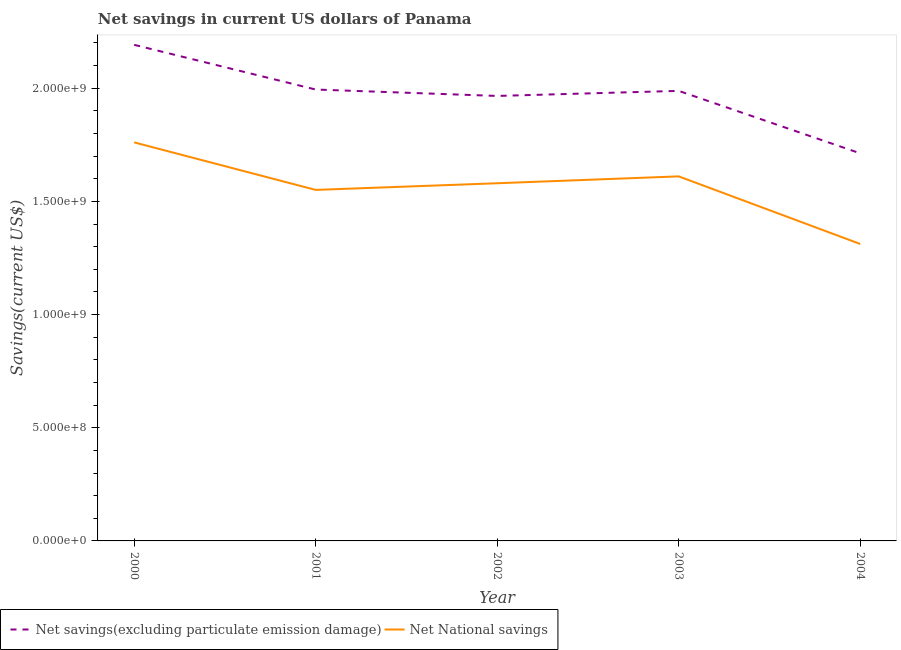What is the net national savings in 2000?
Keep it short and to the point. 1.76e+09. Across all years, what is the maximum net national savings?
Give a very brief answer. 1.76e+09. Across all years, what is the minimum net savings(excluding particulate emission damage)?
Make the answer very short. 1.71e+09. In which year was the net savings(excluding particulate emission damage) maximum?
Keep it short and to the point. 2000. In which year was the net national savings minimum?
Keep it short and to the point. 2004. What is the total net national savings in the graph?
Your answer should be compact. 7.81e+09. What is the difference between the net savings(excluding particulate emission damage) in 2002 and that in 2003?
Keep it short and to the point. -2.24e+07. What is the difference between the net savings(excluding particulate emission damage) in 2001 and the net national savings in 2002?
Make the answer very short. 4.14e+08. What is the average net national savings per year?
Offer a terse response. 1.56e+09. In the year 2003, what is the difference between the net national savings and net savings(excluding particulate emission damage)?
Offer a very short reply. -3.78e+08. What is the ratio of the net savings(excluding particulate emission damage) in 2000 to that in 2001?
Offer a very short reply. 1.1. What is the difference between the highest and the second highest net savings(excluding particulate emission damage)?
Provide a succinct answer. 1.97e+08. What is the difference between the highest and the lowest net national savings?
Provide a short and direct response. 4.49e+08. In how many years, is the net national savings greater than the average net national savings taken over all years?
Keep it short and to the point. 3. Does the net national savings monotonically increase over the years?
Your response must be concise. No. Is the net savings(excluding particulate emission damage) strictly greater than the net national savings over the years?
Your answer should be very brief. Yes. How many years are there in the graph?
Your answer should be compact. 5. Are the values on the major ticks of Y-axis written in scientific E-notation?
Provide a succinct answer. Yes. Does the graph contain grids?
Ensure brevity in your answer.  No. Where does the legend appear in the graph?
Provide a succinct answer. Bottom left. How are the legend labels stacked?
Keep it short and to the point. Horizontal. What is the title of the graph?
Offer a very short reply. Net savings in current US dollars of Panama. Does "State government" appear as one of the legend labels in the graph?
Provide a succinct answer. No. What is the label or title of the X-axis?
Your answer should be very brief. Year. What is the label or title of the Y-axis?
Keep it short and to the point. Savings(current US$). What is the Savings(current US$) of Net savings(excluding particulate emission damage) in 2000?
Offer a terse response. 2.19e+09. What is the Savings(current US$) in Net National savings in 2000?
Offer a very short reply. 1.76e+09. What is the Savings(current US$) in Net savings(excluding particulate emission damage) in 2001?
Offer a terse response. 1.99e+09. What is the Savings(current US$) in Net National savings in 2001?
Offer a very short reply. 1.55e+09. What is the Savings(current US$) in Net savings(excluding particulate emission damage) in 2002?
Make the answer very short. 1.97e+09. What is the Savings(current US$) of Net National savings in 2002?
Keep it short and to the point. 1.58e+09. What is the Savings(current US$) in Net savings(excluding particulate emission damage) in 2003?
Your answer should be compact. 1.99e+09. What is the Savings(current US$) in Net National savings in 2003?
Provide a short and direct response. 1.61e+09. What is the Savings(current US$) of Net savings(excluding particulate emission damage) in 2004?
Offer a terse response. 1.71e+09. What is the Savings(current US$) of Net National savings in 2004?
Offer a very short reply. 1.31e+09. Across all years, what is the maximum Savings(current US$) in Net savings(excluding particulate emission damage)?
Keep it short and to the point. 2.19e+09. Across all years, what is the maximum Savings(current US$) in Net National savings?
Offer a very short reply. 1.76e+09. Across all years, what is the minimum Savings(current US$) of Net savings(excluding particulate emission damage)?
Keep it short and to the point. 1.71e+09. Across all years, what is the minimum Savings(current US$) of Net National savings?
Make the answer very short. 1.31e+09. What is the total Savings(current US$) in Net savings(excluding particulate emission damage) in the graph?
Make the answer very short. 9.85e+09. What is the total Savings(current US$) of Net National savings in the graph?
Offer a terse response. 7.81e+09. What is the difference between the Savings(current US$) of Net savings(excluding particulate emission damage) in 2000 and that in 2001?
Ensure brevity in your answer.  1.97e+08. What is the difference between the Savings(current US$) of Net National savings in 2000 and that in 2001?
Your response must be concise. 2.10e+08. What is the difference between the Savings(current US$) in Net savings(excluding particulate emission damage) in 2000 and that in 2002?
Your answer should be compact. 2.26e+08. What is the difference between the Savings(current US$) of Net National savings in 2000 and that in 2002?
Your answer should be very brief. 1.80e+08. What is the difference between the Savings(current US$) in Net savings(excluding particulate emission damage) in 2000 and that in 2003?
Provide a succinct answer. 2.03e+08. What is the difference between the Savings(current US$) in Net National savings in 2000 and that in 2003?
Make the answer very short. 1.50e+08. What is the difference between the Savings(current US$) in Net savings(excluding particulate emission damage) in 2000 and that in 2004?
Offer a very short reply. 4.79e+08. What is the difference between the Savings(current US$) of Net National savings in 2000 and that in 2004?
Your response must be concise. 4.49e+08. What is the difference between the Savings(current US$) in Net savings(excluding particulate emission damage) in 2001 and that in 2002?
Offer a very short reply. 2.83e+07. What is the difference between the Savings(current US$) of Net National savings in 2001 and that in 2002?
Your answer should be compact. -2.94e+07. What is the difference between the Savings(current US$) of Net savings(excluding particulate emission damage) in 2001 and that in 2003?
Ensure brevity in your answer.  5.92e+06. What is the difference between the Savings(current US$) in Net National savings in 2001 and that in 2003?
Provide a succinct answer. -5.98e+07. What is the difference between the Savings(current US$) in Net savings(excluding particulate emission damage) in 2001 and that in 2004?
Give a very brief answer. 2.82e+08. What is the difference between the Savings(current US$) in Net National savings in 2001 and that in 2004?
Provide a succinct answer. 2.39e+08. What is the difference between the Savings(current US$) in Net savings(excluding particulate emission damage) in 2002 and that in 2003?
Your answer should be very brief. -2.24e+07. What is the difference between the Savings(current US$) in Net National savings in 2002 and that in 2003?
Ensure brevity in your answer.  -3.04e+07. What is the difference between the Savings(current US$) in Net savings(excluding particulate emission damage) in 2002 and that in 2004?
Your answer should be very brief. 2.54e+08. What is the difference between the Savings(current US$) in Net National savings in 2002 and that in 2004?
Make the answer very short. 2.68e+08. What is the difference between the Savings(current US$) of Net savings(excluding particulate emission damage) in 2003 and that in 2004?
Your answer should be very brief. 2.76e+08. What is the difference between the Savings(current US$) in Net National savings in 2003 and that in 2004?
Provide a short and direct response. 2.99e+08. What is the difference between the Savings(current US$) in Net savings(excluding particulate emission damage) in 2000 and the Savings(current US$) in Net National savings in 2001?
Ensure brevity in your answer.  6.41e+08. What is the difference between the Savings(current US$) of Net savings(excluding particulate emission damage) in 2000 and the Savings(current US$) of Net National savings in 2002?
Offer a very short reply. 6.11e+08. What is the difference between the Savings(current US$) of Net savings(excluding particulate emission damage) in 2000 and the Savings(current US$) of Net National savings in 2003?
Provide a succinct answer. 5.81e+08. What is the difference between the Savings(current US$) of Net savings(excluding particulate emission damage) in 2000 and the Savings(current US$) of Net National savings in 2004?
Ensure brevity in your answer.  8.80e+08. What is the difference between the Savings(current US$) in Net savings(excluding particulate emission damage) in 2001 and the Savings(current US$) in Net National savings in 2002?
Your answer should be compact. 4.14e+08. What is the difference between the Savings(current US$) in Net savings(excluding particulate emission damage) in 2001 and the Savings(current US$) in Net National savings in 2003?
Offer a very short reply. 3.84e+08. What is the difference between the Savings(current US$) of Net savings(excluding particulate emission damage) in 2001 and the Savings(current US$) of Net National savings in 2004?
Provide a short and direct response. 6.82e+08. What is the difference between the Savings(current US$) of Net savings(excluding particulate emission damage) in 2002 and the Savings(current US$) of Net National savings in 2003?
Make the answer very short. 3.55e+08. What is the difference between the Savings(current US$) of Net savings(excluding particulate emission damage) in 2002 and the Savings(current US$) of Net National savings in 2004?
Keep it short and to the point. 6.54e+08. What is the difference between the Savings(current US$) of Net savings(excluding particulate emission damage) in 2003 and the Savings(current US$) of Net National savings in 2004?
Provide a succinct answer. 6.76e+08. What is the average Savings(current US$) in Net savings(excluding particulate emission damage) per year?
Provide a succinct answer. 1.97e+09. What is the average Savings(current US$) in Net National savings per year?
Your answer should be very brief. 1.56e+09. In the year 2000, what is the difference between the Savings(current US$) of Net savings(excluding particulate emission damage) and Savings(current US$) of Net National savings?
Offer a very short reply. 4.31e+08. In the year 2001, what is the difference between the Savings(current US$) of Net savings(excluding particulate emission damage) and Savings(current US$) of Net National savings?
Make the answer very short. 4.43e+08. In the year 2002, what is the difference between the Savings(current US$) in Net savings(excluding particulate emission damage) and Savings(current US$) in Net National savings?
Make the answer very short. 3.86e+08. In the year 2003, what is the difference between the Savings(current US$) in Net savings(excluding particulate emission damage) and Savings(current US$) in Net National savings?
Ensure brevity in your answer.  3.78e+08. In the year 2004, what is the difference between the Savings(current US$) of Net savings(excluding particulate emission damage) and Savings(current US$) of Net National savings?
Offer a terse response. 4.00e+08. What is the ratio of the Savings(current US$) in Net savings(excluding particulate emission damage) in 2000 to that in 2001?
Ensure brevity in your answer.  1.1. What is the ratio of the Savings(current US$) of Net National savings in 2000 to that in 2001?
Your response must be concise. 1.14. What is the ratio of the Savings(current US$) in Net savings(excluding particulate emission damage) in 2000 to that in 2002?
Make the answer very short. 1.11. What is the ratio of the Savings(current US$) in Net National savings in 2000 to that in 2002?
Provide a short and direct response. 1.11. What is the ratio of the Savings(current US$) in Net savings(excluding particulate emission damage) in 2000 to that in 2003?
Your answer should be very brief. 1.1. What is the ratio of the Savings(current US$) in Net National savings in 2000 to that in 2003?
Offer a terse response. 1.09. What is the ratio of the Savings(current US$) in Net savings(excluding particulate emission damage) in 2000 to that in 2004?
Provide a succinct answer. 1.28. What is the ratio of the Savings(current US$) of Net National savings in 2000 to that in 2004?
Provide a succinct answer. 1.34. What is the ratio of the Savings(current US$) in Net savings(excluding particulate emission damage) in 2001 to that in 2002?
Keep it short and to the point. 1.01. What is the ratio of the Savings(current US$) in Net National savings in 2001 to that in 2002?
Keep it short and to the point. 0.98. What is the ratio of the Savings(current US$) of Net savings(excluding particulate emission damage) in 2001 to that in 2003?
Offer a very short reply. 1. What is the ratio of the Savings(current US$) in Net National savings in 2001 to that in 2003?
Ensure brevity in your answer.  0.96. What is the ratio of the Savings(current US$) in Net savings(excluding particulate emission damage) in 2001 to that in 2004?
Make the answer very short. 1.16. What is the ratio of the Savings(current US$) in Net National savings in 2001 to that in 2004?
Give a very brief answer. 1.18. What is the ratio of the Savings(current US$) in Net savings(excluding particulate emission damage) in 2002 to that in 2003?
Keep it short and to the point. 0.99. What is the ratio of the Savings(current US$) of Net National savings in 2002 to that in 2003?
Your answer should be compact. 0.98. What is the ratio of the Savings(current US$) of Net savings(excluding particulate emission damage) in 2002 to that in 2004?
Your answer should be very brief. 1.15. What is the ratio of the Savings(current US$) of Net National savings in 2002 to that in 2004?
Make the answer very short. 1.2. What is the ratio of the Savings(current US$) of Net savings(excluding particulate emission damage) in 2003 to that in 2004?
Make the answer very short. 1.16. What is the ratio of the Savings(current US$) of Net National savings in 2003 to that in 2004?
Offer a very short reply. 1.23. What is the difference between the highest and the second highest Savings(current US$) of Net savings(excluding particulate emission damage)?
Offer a terse response. 1.97e+08. What is the difference between the highest and the second highest Savings(current US$) of Net National savings?
Make the answer very short. 1.50e+08. What is the difference between the highest and the lowest Savings(current US$) of Net savings(excluding particulate emission damage)?
Your response must be concise. 4.79e+08. What is the difference between the highest and the lowest Savings(current US$) in Net National savings?
Your answer should be very brief. 4.49e+08. 